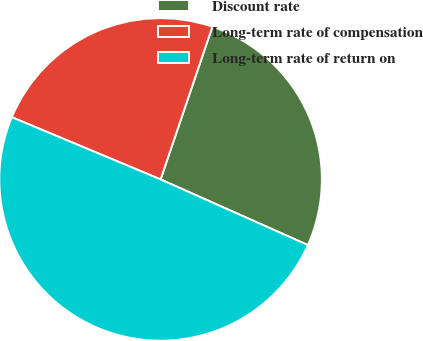<chart> <loc_0><loc_0><loc_500><loc_500><pie_chart><fcel>Discount rate<fcel>Long-term rate of compensation<fcel>Long-term rate of return on<nl><fcel>26.47%<fcel>23.9%<fcel>49.63%<nl></chart> 